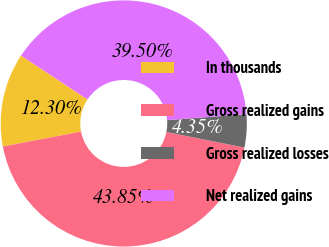Convert chart. <chart><loc_0><loc_0><loc_500><loc_500><pie_chart><fcel>In thousands<fcel>Gross realized gains<fcel>Gross realized losses<fcel>Net realized gains<nl><fcel>12.3%<fcel>43.85%<fcel>4.35%<fcel>39.5%<nl></chart> 